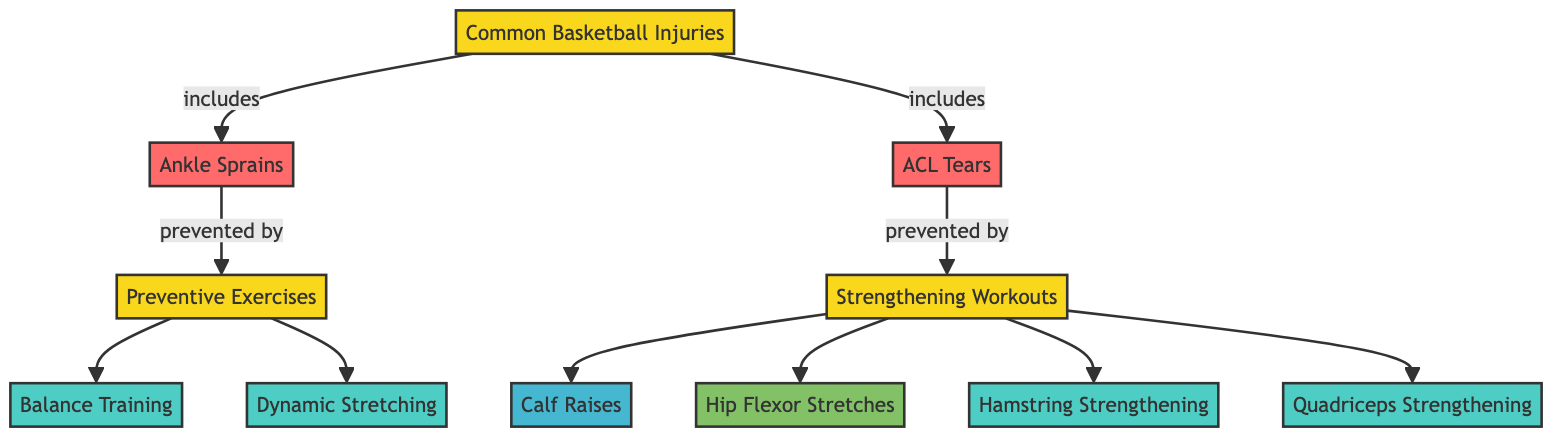What are two common basketball injuries identified in the diagram? The diagram lists two common basketball injuries: Ankle Sprains and ACL Tears. These labels can be found in the node that categorizes common basketball injuries.
Answer: Ankle Sprains, ACL Tears What type of exercises are included under preventive measures in the diagram? The preventive exercises category in the diagram includes Balance Training and Dynamic Stretching, both of which are directly connected to the common basketball injuries node.
Answer: Balance Training, Dynamic Stretching How many strengthening workouts are recommended for preventing ACL tears? In the diagram, there are three specific workouts listed under the strengthening category, which includes Hamstring Strengthening and Quadriceps Strengthening, along with Calf Raises related to other injuries. Therefore, the count is two specifically linked to ACL prevention.
Answer: 2 Which injury is directly associated with balancing and stretching exercises? According to the diagram, Ankle Sprains are directly linked to the preventive exercises of Balance Training and Dynamic Stretching. Hence, these exercises directly help in preventing this specific injury.
Answer: Ankle Sprains What is the relationship between ACL tears and strengthening workouts? The diagram explicitly states that ACL tears are prevented by the category of strengthening workouts, showing a direct connection indicating that strengthening the muscles helps avoid this injury.
Answer: Prevented by strengthening workouts How many nodes represent preventive exercises in this diagram? The preventive exercises category in the diagram has two individual nodes: Balance Training and Dynamic Stretching, which means there are two nodes representing these exercises.
Answer: 2 What are two types of strengthening workouts listed in the diagram? The diagram provides two types of strengthening workouts: Hamstring Strengthening and Quadriceps Strengthening, both of which aim to enhance muscle strength to prevent injuries.
Answer: Hamstring Strengthening, Quadriceps Strengthening Which injury in the diagram is associated with calf raises as a preventative measure? The calf raises are associated with ankle sprains, as indicated in the diagram and reflecting its purpose in strengthening to prevent that specific injury.
Answer: Ankle Sprains 